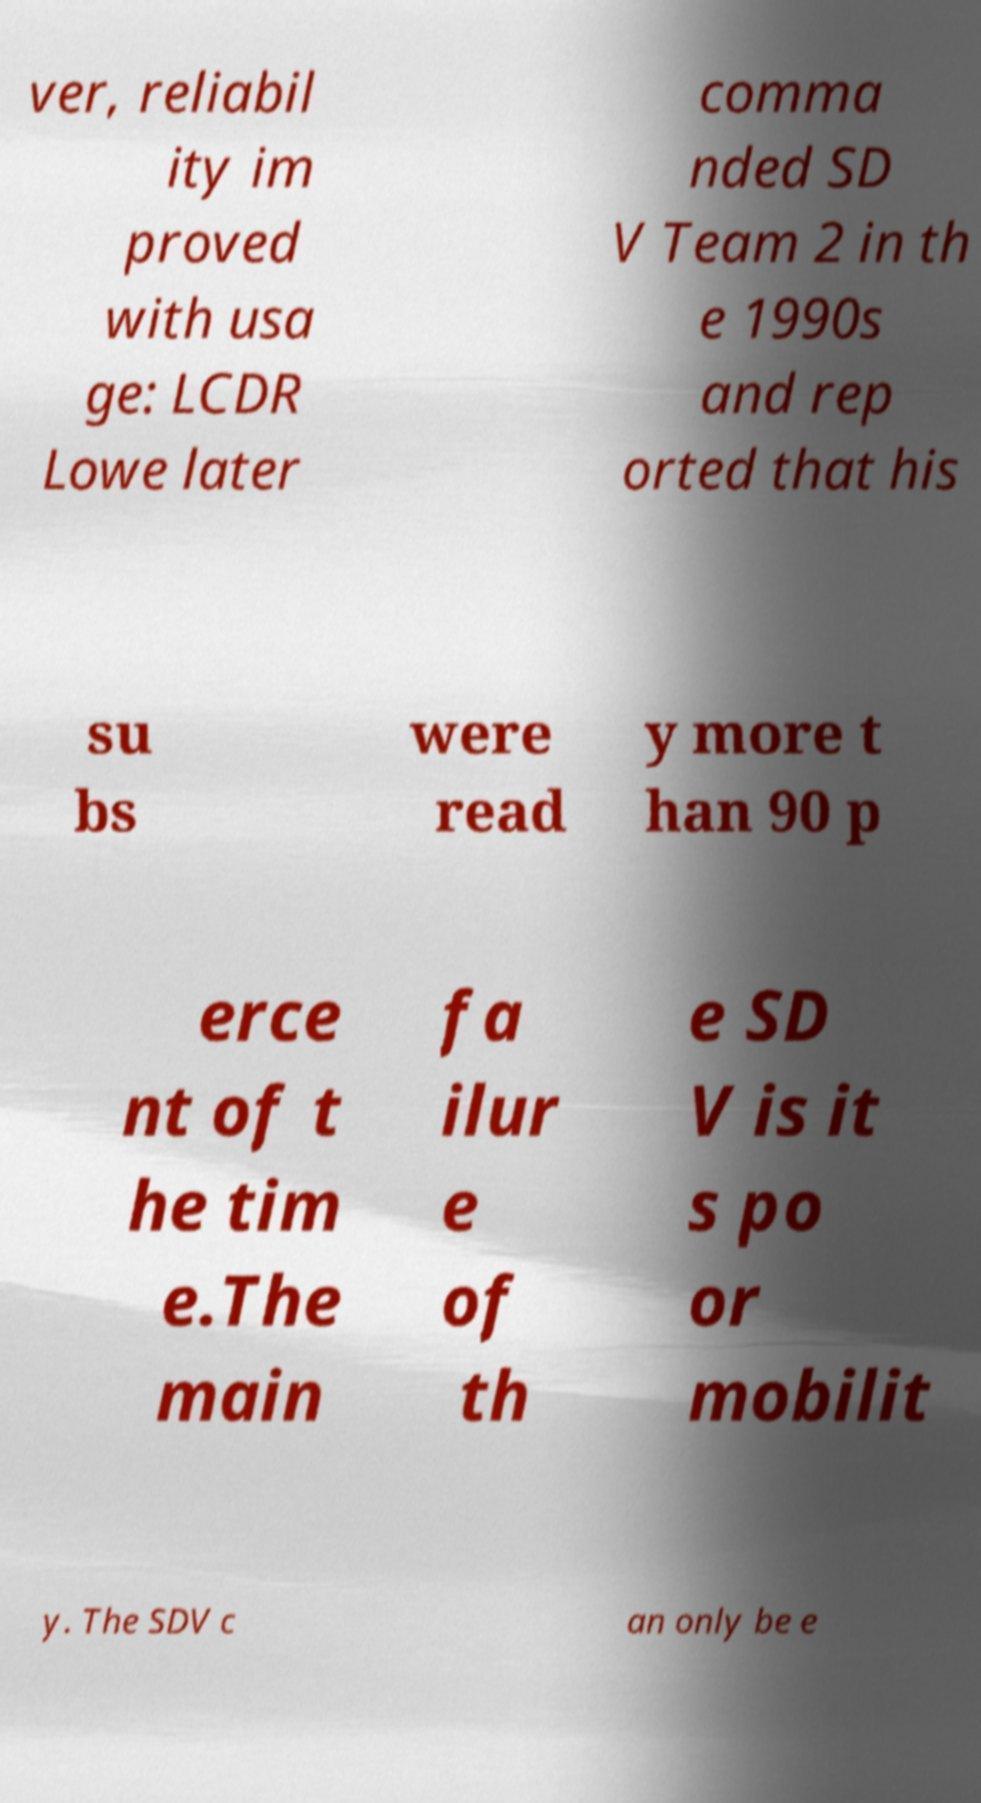Can you accurately transcribe the text from the provided image for me? ver, reliabil ity im proved with usa ge: LCDR Lowe later comma nded SD V Team 2 in th e 1990s and rep orted that his su bs were read y more t han 90 p erce nt of t he tim e.The main fa ilur e of th e SD V is it s po or mobilit y. The SDV c an only be e 